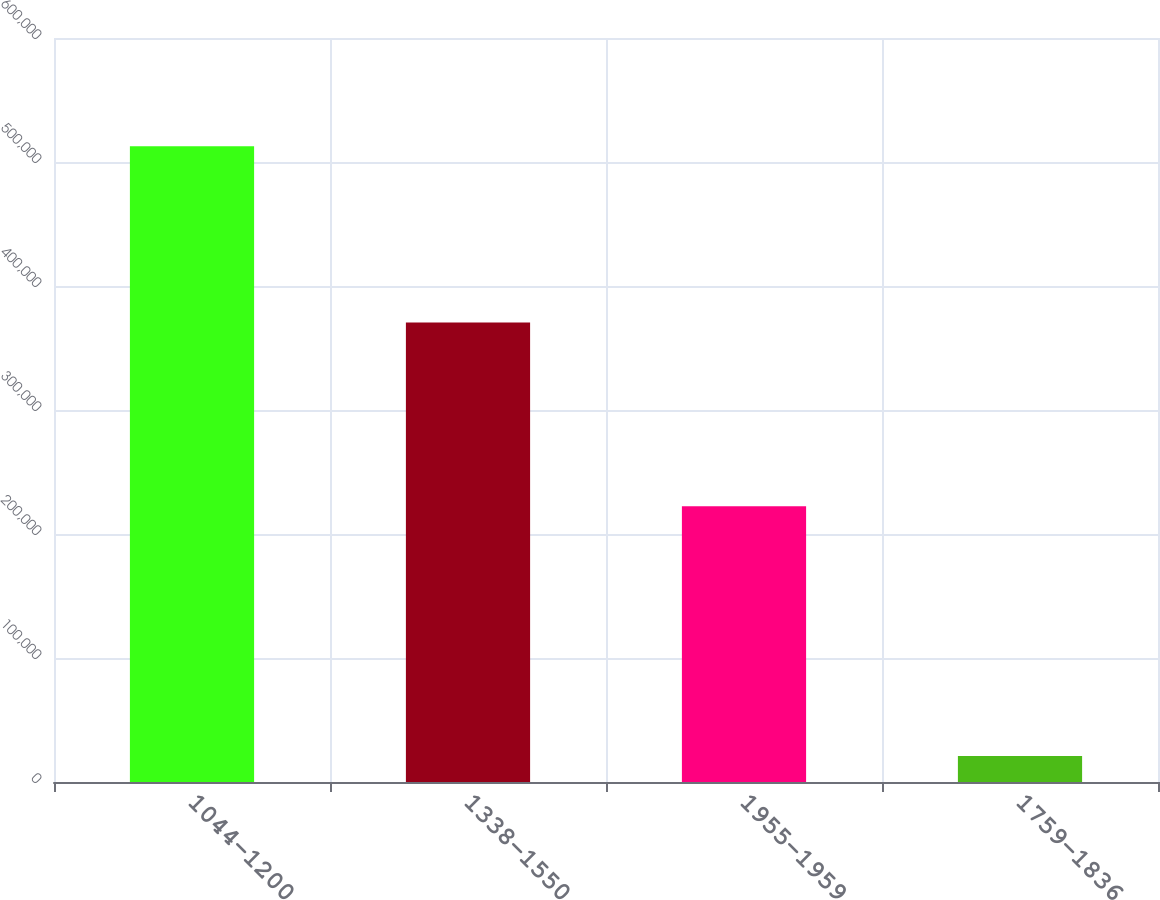<chart> <loc_0><loc_0><loc_500><loc_500><bar_chart><fcel>1044-1200<fcel>1338-1550<fcel>1955-1959<fcel>1759-1836<nl><fcel>512622<fcel>370661<fcel>222293<fcel>21000<nl></chart> 